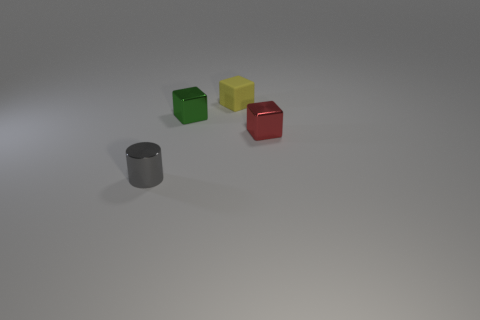Are there fewer tiny red metallic cubes behind the small green metallic cube than tiny gray shiny objects?
Ensure brevity in your answer.  Yes. What number of green metal blocks are the same size as the yellow cube?
Offer a very short reply. 1. Is the color of the tiny object to the right of the tiny yellow cube the same as the tiny metal object behind the red metal cube?
Offer a very short reply. No. There is a red block; how many red cubes are right of it?
Provide a succinct answer. 0. Is there a small rubber thing that has the same shape as the green metal object?
Make the answer very short. Yes. The other matte object that is the same size as the gray thing is what color?
Keep it short and to the point. Yellow. Are there fewer cubes to the right of the small metal cylinder than tiny red things that are left of the yellow rubber cube?
Provide a short and direct response. No. Is the size of the metal cube that is in front of the green block the same as the metallic cylinder?
Keep it short and to the point. Yes. There is a tiny object right of the rubber object; what shape is it?
Offer a very short reply. Cube. Are there more purple shiny balls than small gray metal things?
Offer a terse response. No. 